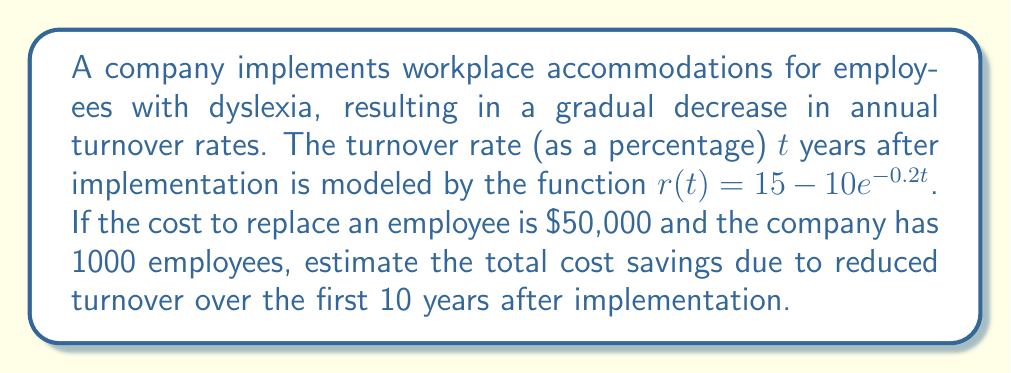Solve this math problem. To solve this problem, we need to follow these steps:

1) First, we need to find the turnover rate at the beginning (t = 0) and after 10 years (t = 10):

   At t = 0: $r(0) = 15 - 10e^{-0.2(0)} = 15 - 10 = 5\%$
   At t = 10: $r(10) = 15 - 10e^{-0.2(10)} \approx 12.64\%$

2) The average turnover rate over the 10-year period can be estimated by integrating the function $r(t)$ from 0 to 10 and dividing by 10:

   Average rate = $\frac{1}{10}\int_0^{10} (15 - 10e^{-0.2t}) dt$

3) Let's solve this integral:

   $\frac{1}{10}[15t + 50e^{-0.2t}]_0^{10}$
   
   $= \frac{1}{10}[(150 + 50e^{-2}) - (0 + 50)]$
   
   $\approx 10.92\%$

4) The difference between the initial turnover rate and the average rate over 10 years:

   $5\% - 10.92\% = -5.92\%$

5) This represents the average annual reduction in turnover rate.

6) For a company with 1000 employees, this means approximately 59.2 fewer employees leaving each year on average.

7) With a replacement cost of $50,000 per employee, the annual savings are:

   $59.2 * $50,000 = $2,960,000$

8) Over 10 years, the total savings would be:

   $10 * $2,960,000 = $29,600,000$
Answer: The estimated total cost savings due to reduced turnover over the first 10 years after implementation is $29,600,000. 